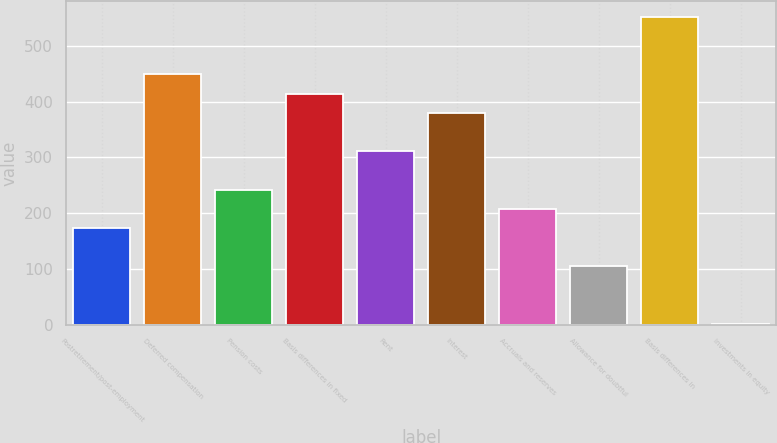Convert chart to OTSL. <chart><loc_0><loc_0><loc_500><loc_500><bar_chart><fcel>Postretirement/post-employment<fcel>Deferred compensation<fcel>Pension costs<fcel>Basis differences in fixed<fcel>Rent<fcel>Interest<fcel>Accruals and reserves<fcel>Allowance for doubtful<fcel>Basis differences in<fcel>Investments in equity<nl><fcel>173.4<fcel>448.92<fcel>242.28<fcel>414.48<fcel>311.16<fcel>380.04<fcel>207.84<fcel>104.52<fcel>552.24<fcel>1.2<nl></chart> 